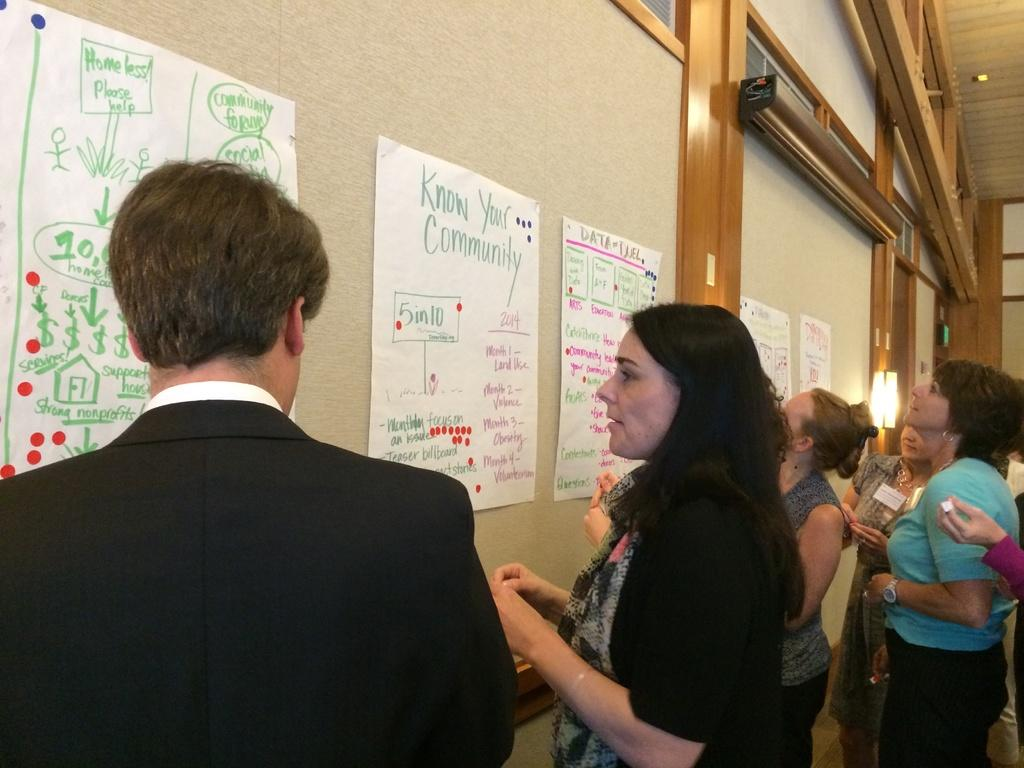How many people are in the image? There is a group of people standing in the image. What can be seen attached to the wall in the image? There are pipes attached to the wall in the image. What is visible in the background of the image? There are objects visible in the background of the image. What type of appliance is resting on the middle of the group of people in the image? There is no appliance resting on the middle of the group of people in the image. 